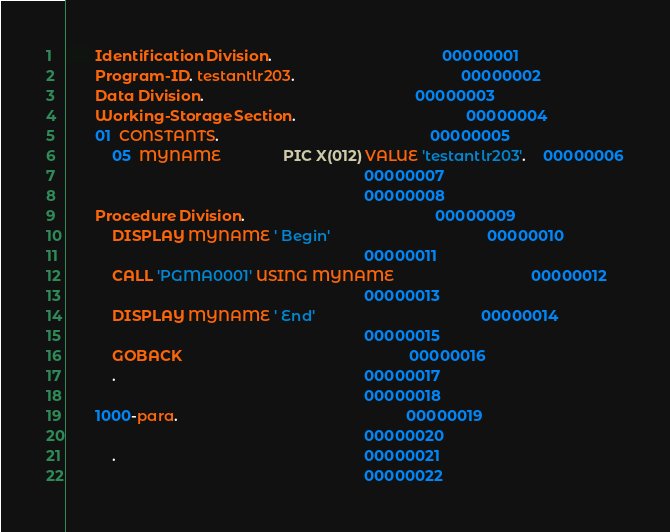<code> <loc_0><loc_0><loc_500><loc_500><_COBOL_>       Identification Division.                                         00000001
       Program-ID. testantlr203.                                        00000002
       Data Division.                                                   00000003
       Working-Storage Section.                                         00000004
       01  CONSTANTS.                                                   00000005
           05  MYNAME               PIC X(012) VALUE 'testantlr203'.    00000006
                                                                        00000007
                                                                        00000008
       Procedure Division.                                              00000009
           DISPLAY MYNAME ' Begin'                                      00000010
                                                                        00000011
           CALL 'PGMA0001' USING MYNAME                                 00000012
                                                                        00000013
           DISPLAY MYNAME ' End'                                        00000014
                                                                        00000015
           GOBACK                                                       00000016
           .                                                            00000017
                                                                        00000018
       1000-para.                                                       00000019
                                                                        00000020
           .                                                            00000021
                                                                        00000022
</code> 